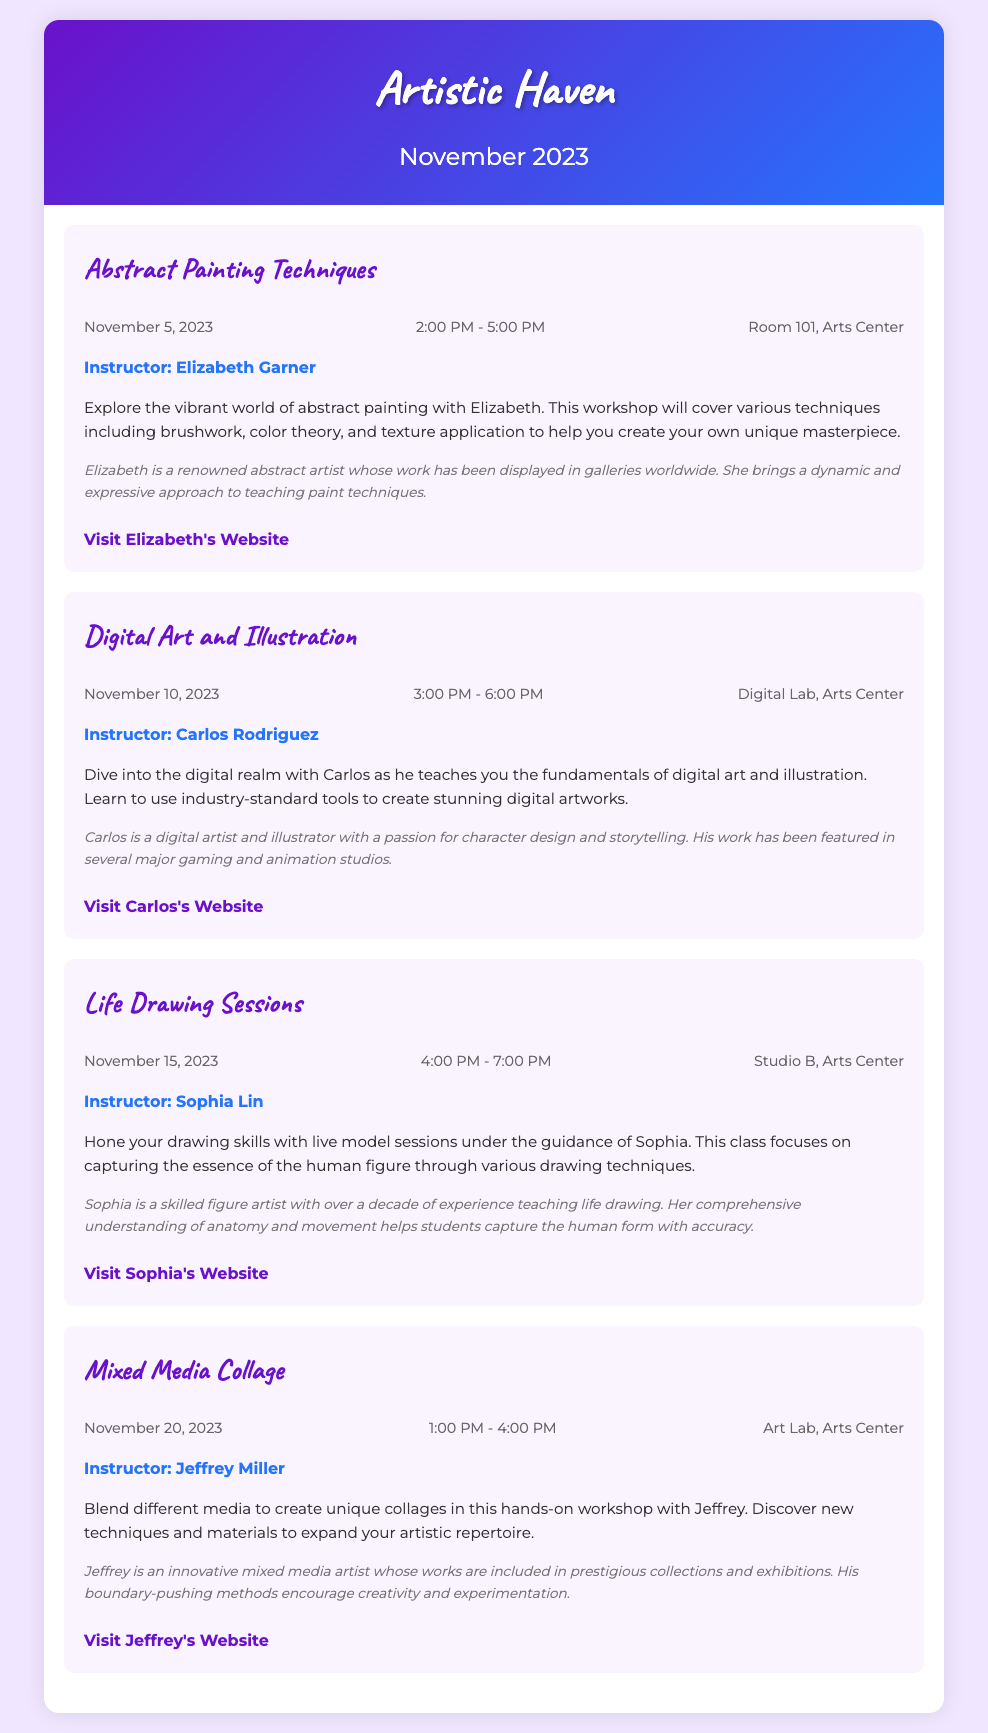What is the title of the first workshop? The title of the first workshop is located at the beginning of the first class item in the document.
Answer: Abstract Painting Techniques Who is the instructor for the Digital Art and Illustration class? The instructor's name is given immediately after the class title for this particular class.
Answer: Carlos Rodriguez On what date is the Life Drawing Sessions scheduled? The date for this class can be found within the class details section.
Answer: November 15, 2023 How long is the Mixed Media Collage workshop? The duration of each class can be deduced from the class time details provided in the document.
Answer: 3 hours What is the location of the Abstract Painting Techniques workshop? The location is stated in the class details section for this workshop.
Answer: Room 101, Arts Center Which instructor has experience in character design? The document mentions the experience and specialty of the instructors under their bios; for this instructor, it is stated specifically.
Answer: Carlos Rodriguez What day of the week is November 5, 2023? Understanding the date mentioned allows for analyzing the calendar date in context for that month.
Answer: Sunday What artistic approach does Elizabeth Garner bring to her teaching? Insights into the instructor's teaching style can be extracted from their bio in the respective class item.
Answer: Dynamic and expressive 